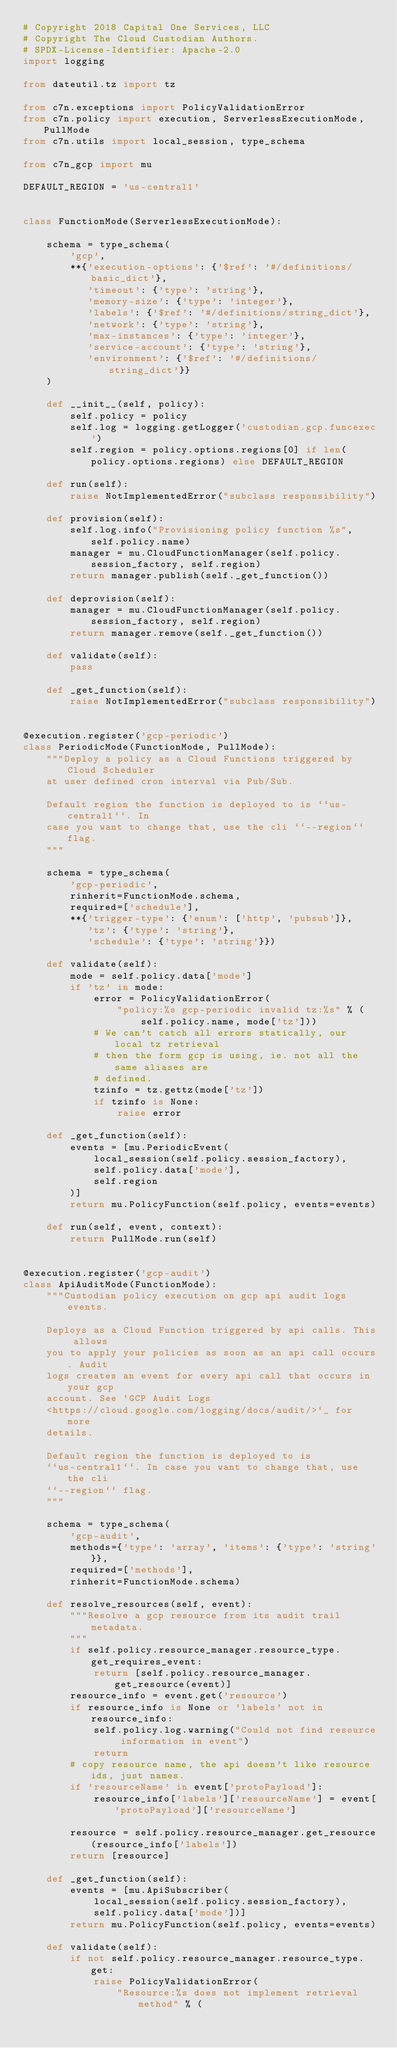<code> <loc_0><loc_0><loc_500><loc_500><_Python_># Copyright 2018 Capital One Services, LLC
# Copyright The Cloud Custodian Authors.
# SPDX-License-Identifier: Apache-2.0
import logging

from dateutil.tz import tz

from c7n.exceptions import PolicyValidationError
from c7n.policy import execution, ServerlessExecutionMode, PullMode
from c7n.utils import local_session, type_schema

from c7n_gcp import mu

DEFAULT_REGION = 'us-central1'


class FunctionMode(ServerlessExecutionMode):

    schema = type_schema(
        'gcp',
        **{'execution-options': {'$ref': '#/definitions/basic_dict'},
           'timeout': {'type': 'string'},
           'memory-size': {'type': 'integer'},
           'labels': {'$ref': '#/definitions/string_dict'},
           'network': {'type': 'string'},
           'max-instances': {'type': 'integer'},
           'service-account': {'type': 'string'},
           'environment': {'$ref': '#/definitions/string_dict'}}
    )

    def __init__(self, policy):
        self.policy = policy
        self.log = logging.getLogger('custodian.gcp.funcexec')
        self.region = policy.options.regions[0] if len(policy.options.regions) else DEFAULT_REGION

    def run(self):
        raise NotImplementedError("subclass responsibility")

    def provision(self):
        self.log.info("Provisioning policy function %s", self.policy.name)
        manager = mu.CloudFunctionManager(self.policy.session_factory, self.region)
        return manager.publish(self._get_function())

    def deprovision(self):
        manager = mu.CloudFunctionManager(self.policy.session_factory, self.region)
        return manager.remove(self._get_function())

    def validate(self):
        pass

    def _get_function(self):
        raise NotImplementedError("subclass responsibility")


@execution.register('gcp-periodic')
class PeriodicMode(FunctionMode, PullMode):
    """Deploy a policy as a Cloud Functions triggered by Cloud Scheduler
    at user defined cron interval via Pub/Sub.

    Default region the function is deployed to is ``us-central1``. In
    case you want to change that, use the cli ``--region`` flag.
    """

    schema = type_schema(
        'gcp-periodic',
        rinherit=FunctionMode.schema,
        required=['schedule'],
        **{'trigger-type': {'enum': ['http', 'pubsub']},
           'tz': {'type': 'string'},
           'schedule': {'type': 'string'}})

    def validate(self):
        mode = self.policy.data['mode']
        if 'tz' in mode:
            error = PolicyValidationError(
                "policy:%s gcp-periodic invalid tz:%s" % (
                    self.policy.name, mode['tz']))
            # We can't catch all errors statically, our local tz retrieval
            # then the form gcp is using, ie. not all the same aliases are
            # defined.
            tzinfo = tz.gettz(mode['tz'])
            if tzinfo is None:
                raise error

    def _get_function(self):
        events = [mu.PeriodicEvent(
            local_session(self.policy.session_factory),
            self.policy.data['mode'],
            self.region
        )]
        return mu.PolicyFunction(self.policy, events=events)

    def run(self, event, context):
        return PullMode.run(self)


@execution.register('gcp-audit')
class ApiAuditMode(FunctionMode):
    """Custodian policy execution on gcp api audit logs events.

    Deploys as a Cloud Function triggered by api calls. This allows
    you to apply your policies as soon as an api call occurs. Audit
    logs creates an event for every api call that occurs in your gcp
    account. See `GCP Audit Logs
    <https://cloud.google.com/logging/docs/audit/>`_ for more
    details.

    Default region the function is deployed to is
    ``us-central1``. In case you want to change that, use the cli
    ``--region`` flag.
    """

    schema = type_schema(
        'gcp-audit',
        methods={'type': 'array', 'items': {'type': 'string'}},
        required=['methods'],
        rinherit=FunctionMode.schema)

    def resolve_resources(self, event):
        """Resolve a gcp resource from its audit trail metadata.
        """
        if self.policy.resource_manager.resource_type.get_requires_event:
            return [self.policy.resource_manager.get_resource(event)]
        resource_info = event.get('resource')
        if resource_info is None or 'labels' not in resource_info:
            self.policy.log.warning("Could not find resource information in event")
            return
        # copy resource name, the api doesn't like resource ids, just names.
        if 'resourceName' in event['protoPayload']:
            resource_info['labels']['resourceName'] = event['protoPayload']['resourceName']

        resource = self.policy.resource_manager.get_resource(resource_info['labels'])
        return [resource]

    def _get_function(self):
        events = [mu.ApiSubscriber(
            local_session(self.policy.session_factory),
            self.policy.data['mode'])]
        return mu.PolicyFunction(self.policy, events=events)

    def validate(self):
        if not self.policy.resource_manager.resource_type.get:
            raise PolicyValidationError(
                "Resource:%s does not implement retrieval method" % (</code> 